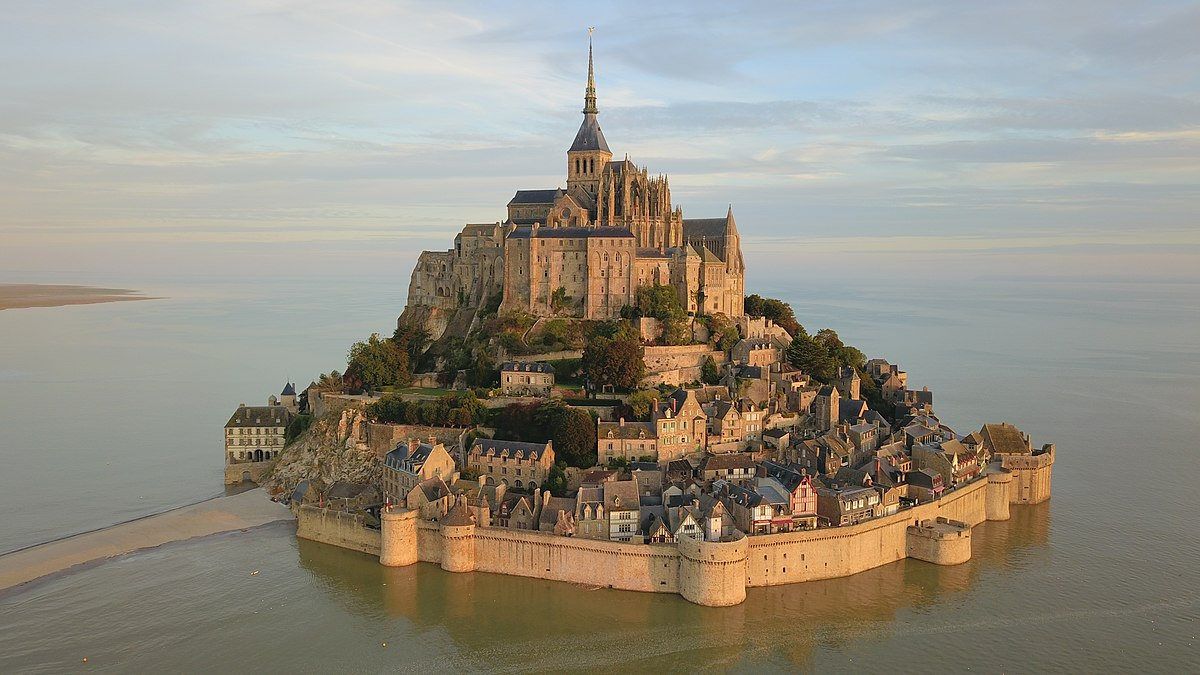What role has Mont St Michel played in French history? Mont St Michel holds a significant place in French history primarily as a strategic fortification, a pilgrimage center, and a cultural symbol. It was an impregnable fortress during numerous conflicts including the Hundred Years' War, representing a site of considerable military importance. Moreover, it was a major pilgrimage destination during the medieval period owing to its religious sanctity as the seat of the Archangel Michael's shrine. Over centuries, it has become an emblem of national identity and resilience, echoing the cultural, historical, and spiritual journey of France. 